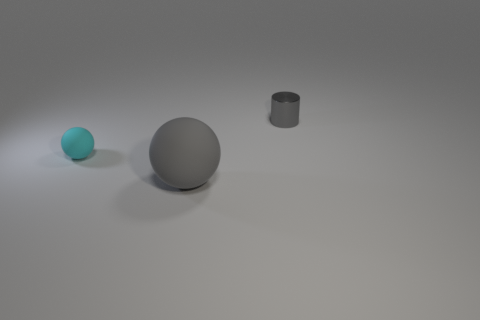Add 2 blue blocks. How many objects exist? 5 Subtract all cylinders. How many objects are left? 2 Add 1 cylinders. How many cylinders are left? 2 Add 2 tiny blocks. How many tiny blocks exist? 2 Subtract 0 brown cubes. How many objects are left? 3 Subtract all small green rubber cubes. Subtract all gray spheres. How many objects are left? 2 